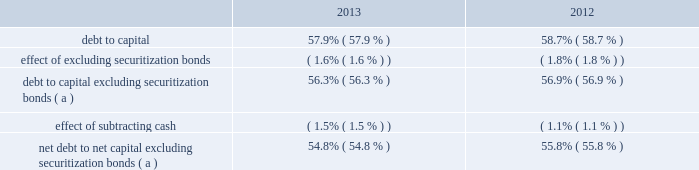Human capital management strategic imperative entergy engaged in a strategic imperative intended to optimize the organization through a process known as human capital management .
In july 2013 management completed a comprehensive review of entergy 2019s organization design and processes .
This effort resulted in a new internal organization structure , which resulted in the elimination of approximately 800 employee positions .
Entergy incurred approximately $ 110 million in costs in 2013 associated with this phase of human capital management , primarily implementation costs , severance expenses , pension curtailment losses , special termination benefits expense , and corporate property , plant , and equipment impairments .
In december 2013 , entergy deferred for future recovery approximately $ 45 million of these costs , as approved by the apsc and the lpsc .
See note 2 to the financial statements for details of the deferrals and note 13 to the financial statements for details of the restructuring charges .
Liquidity and capital resources this section discusses entergy 2019s capital structure , capital spending plans and other uses of capital , sources of capital , and the cash flow activity presented in the cash flow statement .
Capital structure entergy 2019s capitalization is balanced between equity and debt , as shown in the table. .
( a ) calculation excludes the arkansas , louisiana , and texas securitization bonds , which are non-recourse to entergy arkansas , entergy louisiana , and entergy texas , respectively .
Net debt consists of debt less cash and cash equivalents .
Debt consists of notes payable and commercial paper , capital lease obligations , and long-term debt , including the currently maturing portion .
Capital consists of debt , common shareholders 2019 equity , and subsidiaries 2019 preferred stock without sinking fund .
Net capital consists of capital less cash and cash equivalents .
Entergy uses the debt to capital ratios excluding securitization bonds in analyzing its financial condition and believes they provide useful information to its investors and creditors in evaluating entergy 2019s financial condition because the securitization bonds are non-recourse to entergy , as more fully described in note 5 to the financial statements .
Entergy also uses the net debt to net capital ratio excluding securitization bonds in analyzing its financial condition and believes it provides useful information to its investors and creditors in evaluating entergy 2019s financial condition because net debt indicates entergy 2019s outstanding debt position that could not be readily satisfied by cash and cash equivalents on hand .
Long-term debt , including the currently maturing portion , makes up most of entergy 2019s total debt outstanding .
Following are entergy 2019s long-term debt principal maturities and estimated interest payments as of december 31 , 2013 .
To estimate future interest payments for variable rate debt , entergy used the rate as of december 31 , 2013 .
The amounts below include payments on the entergy louisiana and system energy sale-leaseback transactions , which are included in long-term debt on the balance sheet .
Entergy corporation and subsidiaries management's financial discussion and analysis .
What is the percentage change in debt-to-capital ratio from 2012 to 2013? 
Computations: ((57.9 - 58.7) / 58.7)
Answer: -0.01363. Human capital management strategic imperative entergy engaged in a strategic imperative intended to optimize the organization through a process known as human capital management .
In july 2013 management completed a comprehensive review of entergy 2019s organization design and processes .
This effort resulted in a new internal organization structure , which resulted in the elimination of approximately 800 employee positions .
Entergy incurred approximately $ 110 million in costs in 2013 associated with this phase of human capital management , primarily implementation costs , severance expenses , pension curtailment losses , special termination benefits expense , and corporate property , plant , and equipment impairments .
In december 2013 , entergy deferred for future recovery approximately $ 45 million of these costs , as approved by the apsc and the lpsc .
See note 2 to the financial statements for details of the deferrals and note 13 to the financial statements for details of the restructuring charges .
Liquidity and capital resources this section discusses entergy 2019s capital structure , capital spending plans and other uses of capital , sources of capital , and the cash flow activity presented in the cash flow statement .
Capital structure entergy 2019s capitalization is balanced between equity and debt , as shown in the table. .
( a ) calculation excludes the arkansas , louisiana , and texas securitization bonds , which are non-recourse to entergy arkansas , entergy louisiana , and entergy texas , respectively .
Net debt consists of debt less cash and cash equivalents .
Debt consists of notes payable and commercial paper , capital lease obligations , and long-term debt , including the currently maturing portion .
Capital consists of debt , common shareholders 2019 equity , and subsidiaries 2019 preferred stock without sinking fund .
Net capital consists of capital less cash and cash equivalents .
Entergy uses the debt to capital ratios excluding securitization bonds in analyzing its financial condition and believes they provide useful information to its investors and creditors in evaluating entergy 2019s financial condition because the securitization bonds are non-recourse to entergy , as more fully described in note 5 to the financial statements .
Entergy also uses the net debt to net capital ratio excluding securitization bonds in analyzing its financial condition and believes it provides useful information to its investors and creditors in evaluating entergy 2019s financial condition because net debt indicates entergy 2019s outstanding debt position that could not be readily satisfied by cash and cash equivalents on hand .
Long-term debt , including the currently maturing portion , makes up most of entergy 2019s total debt outstanding .
Following are entergy 2019s long-term debt principal maturities and estimated interest payments as of december 31 , 2013 .
To estimate future interest payments for variable rate debt , entergy used the rate as of december 31 , 2013 .
The amounts below include payments on the entergy louisiana and system energy sale-leaseback transactions , which are included in long-term debt on the balance sheet .
Entergy corporation and subsidiaries management's financial discussion and analysis .
What is the percentage change in net debt to net capital excluding securitization bonds from 2012 to 2013? 
Computations: ((54.8 - 55.8) / 55.8)
Answer: -0.01792. 